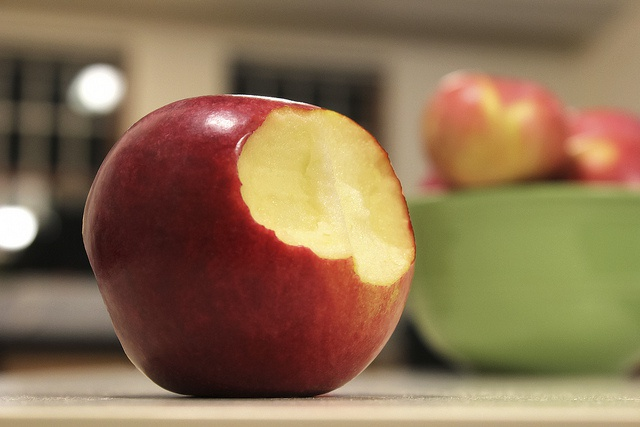Describe the objects in this image and their specific colors. I can see apple in gray, maroon, black, and khaki tones, bowl in gray and olive tones, dining table in gray and tan tones, and apple in gray, salmon, tan, brown, and red tones in this image. 